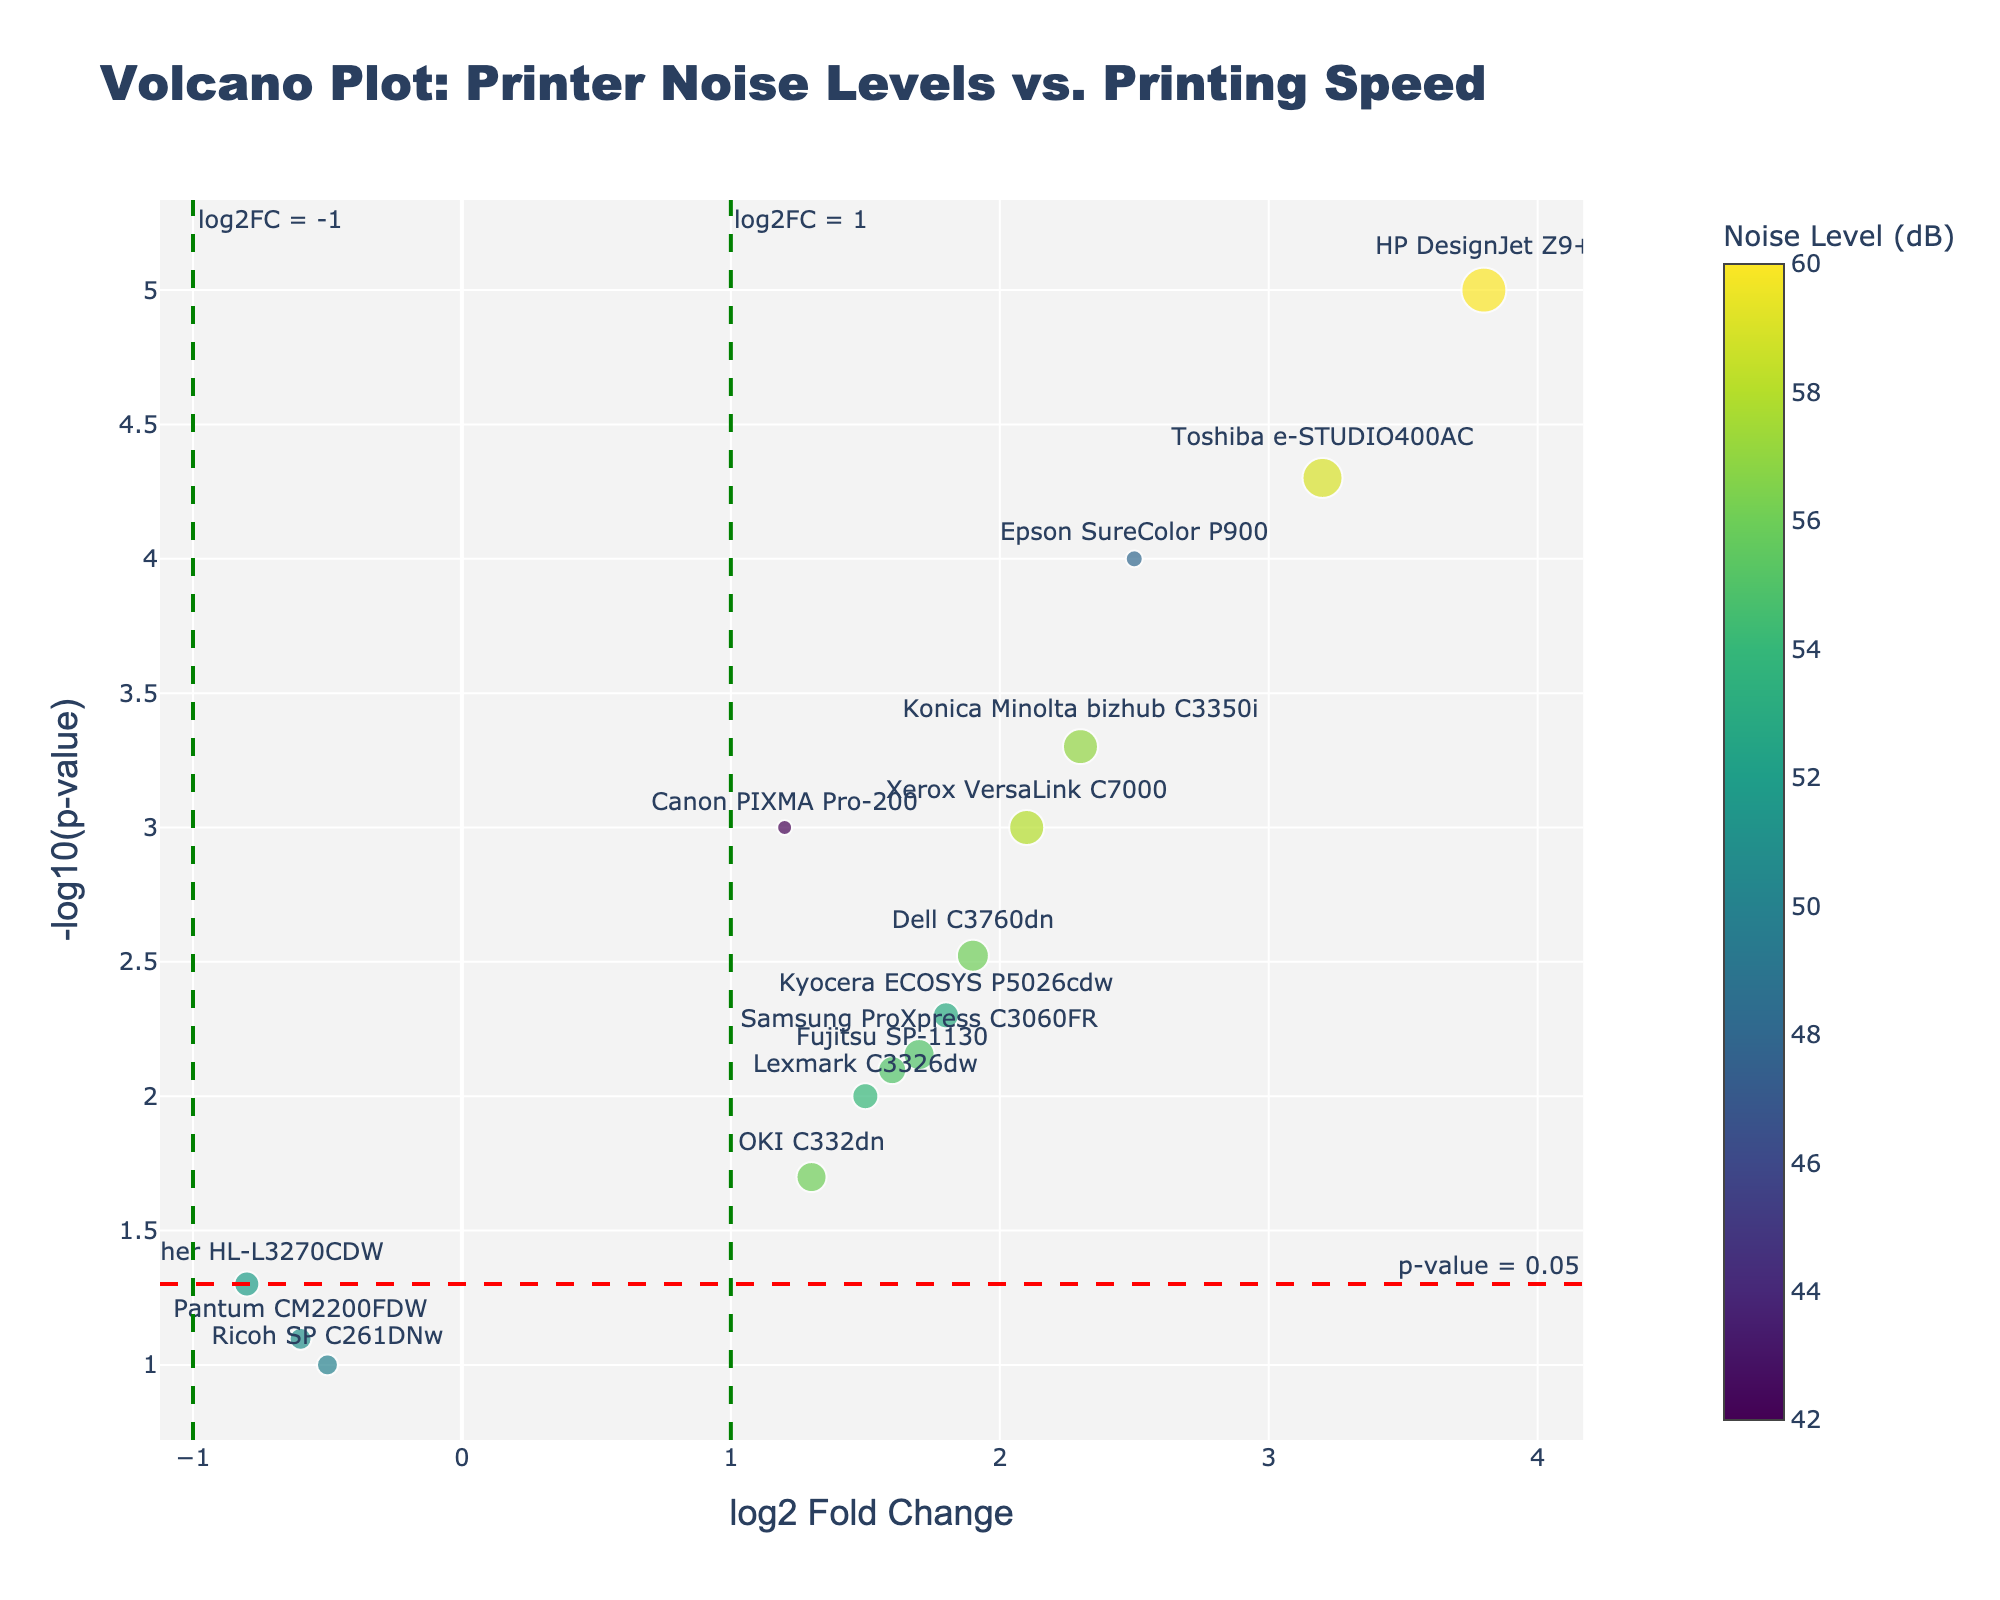How many printers are represented in the plot? Count the number of different printer models represented by the data points on the plot. Each data point is labeled with a printer model. By counting these labels, you can determine the number of printers.
Answer: 15 What does the size of each marker represent on the plot? Refer to the hover template or legend on the plot. The size of the marker is proportional to the printing speed of each printer model, measured in pages per minute (ppm).
Answer: Printing speed How is the color of the markers determined in the plot? Refer to the color scale or legend in the plot. The color of each marker corresponds to the noise level of each printer model, measured in decibels (dB). The color intensity indicates the noise level from the Viridis color scale.
Answer: Noise level Which printer model has the highest noise level? Identify the data point with the darkest color on the Viridis scale, corresponding to the highest noise level. Then, reference the printer model label for that data point.
Answer: HP DesignJet Z9+ Which printer model has the lowest p-value and what is its '-log10(p-value)'? Locate the data point with the highest y-axis value, as '-log10(p-value)' increases as the p-value decreases. Then inspect the hover information or label to find the p-value and '-log10(p-value)'.
Answer: HP DesignJet Z9+, 5 How many printers have a significant p-value below 0.05? Explore the plot and count the number of data points positioned above the horizontal threshold line at -log10(0.05). These data points represent models with p-values below 0.05.
Answer: 11 Which printer has the highest log2 fold change? Identify the data point furthest to the right on the x-axis. The furthest point represents the printer model with the highest log2 fold change. Reference the label next to this point.
Answer: HP DesignJet Z9+ Which printer models demonstrate a negative log2 fold change? Look for data points on the left side of the vertical reference line at log2FC = 0. These points indicate printer models with negative log2 fold changes. Note the labels for these data points.
Answer: Brother HL-L3270CDW, Ricoh SP C261DNw, Pantum CM2200FDW Which printer models have a log2 fold change above 2 and significant p-values? Focus on data points to the right of log2FC = 2 and above the p-value threshold line at -log10(0.05). List the printer models corresponding to these points.
Answer: Epson SureColor P900, HP DesignJet Z9+, Konica Minolta bizhub C3350i, Toshiba e-STUDIO400AC What is the relationship between printing speed and marker size and describe the Canon PIXMA Pro-200 in this context? The marker size on the plot is proportional to the printing speed. Larger markers indicate higher printing speeds. Inspect the marker size for Canon PIXMA Pro-200 and compare it to others.
Answer: Smaller marker size, printing speed of 15 ppm 